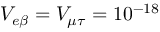<formula> <loc_0><loc_0><loc_500><loc_500>V _ { e \beta } = V _ { \mu \tau } = 1 0 ^ { - 1 8 }</formula> 